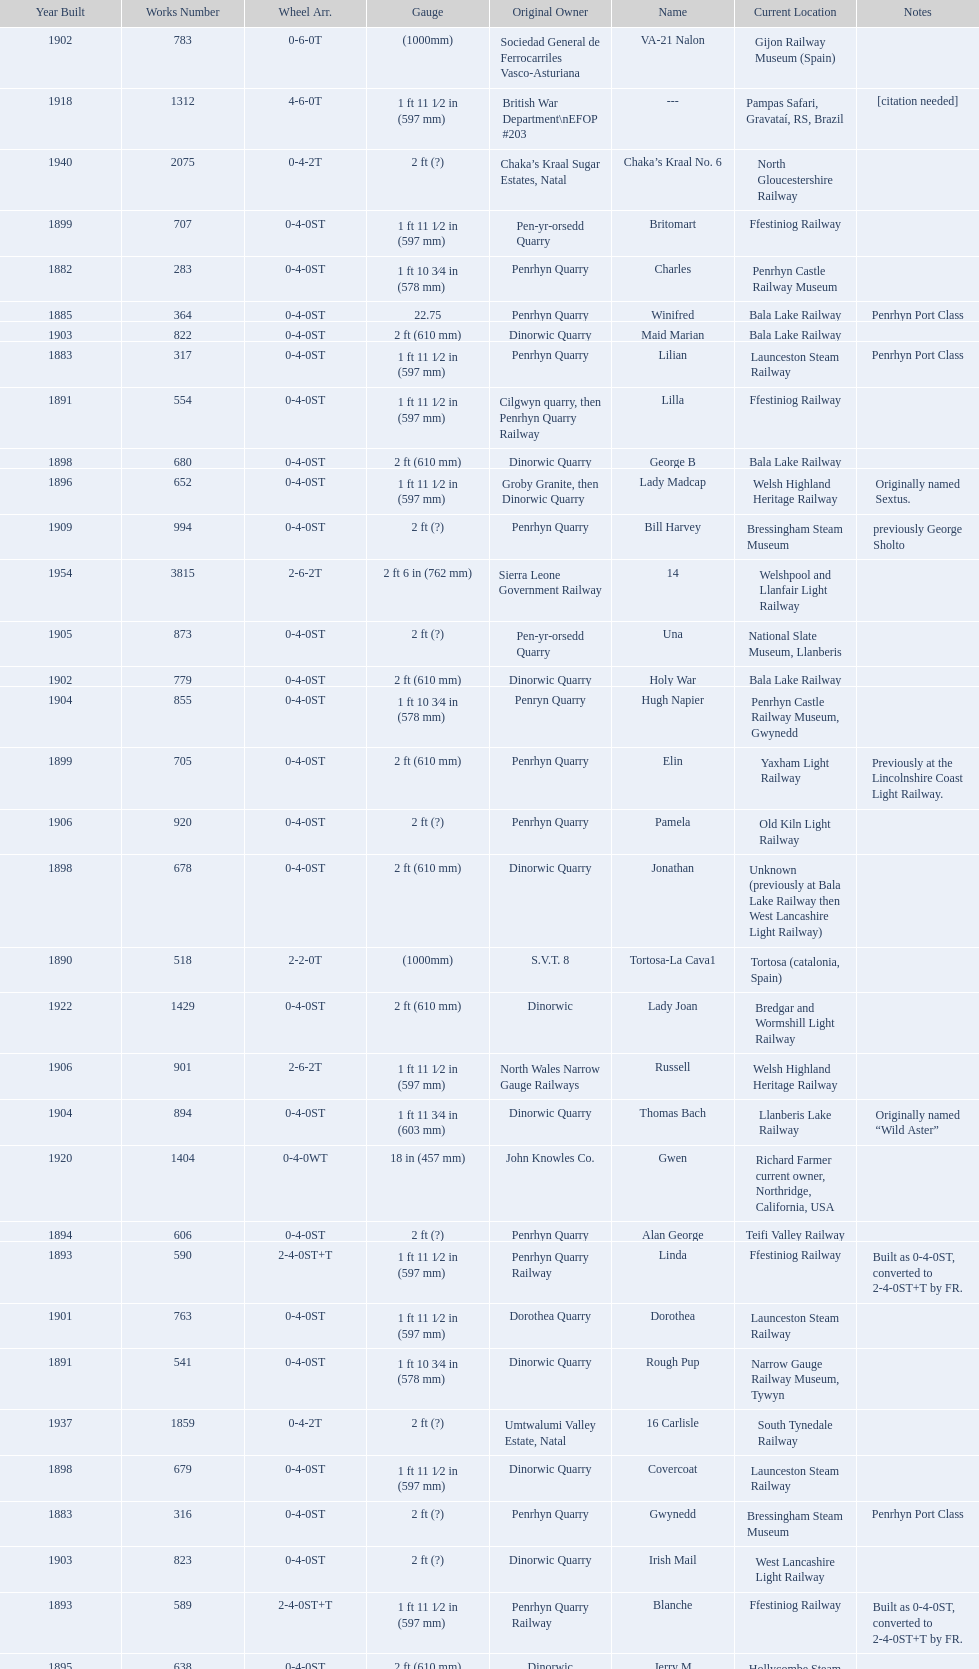Aside from 316, what was the other works number used in 1883? 317. 